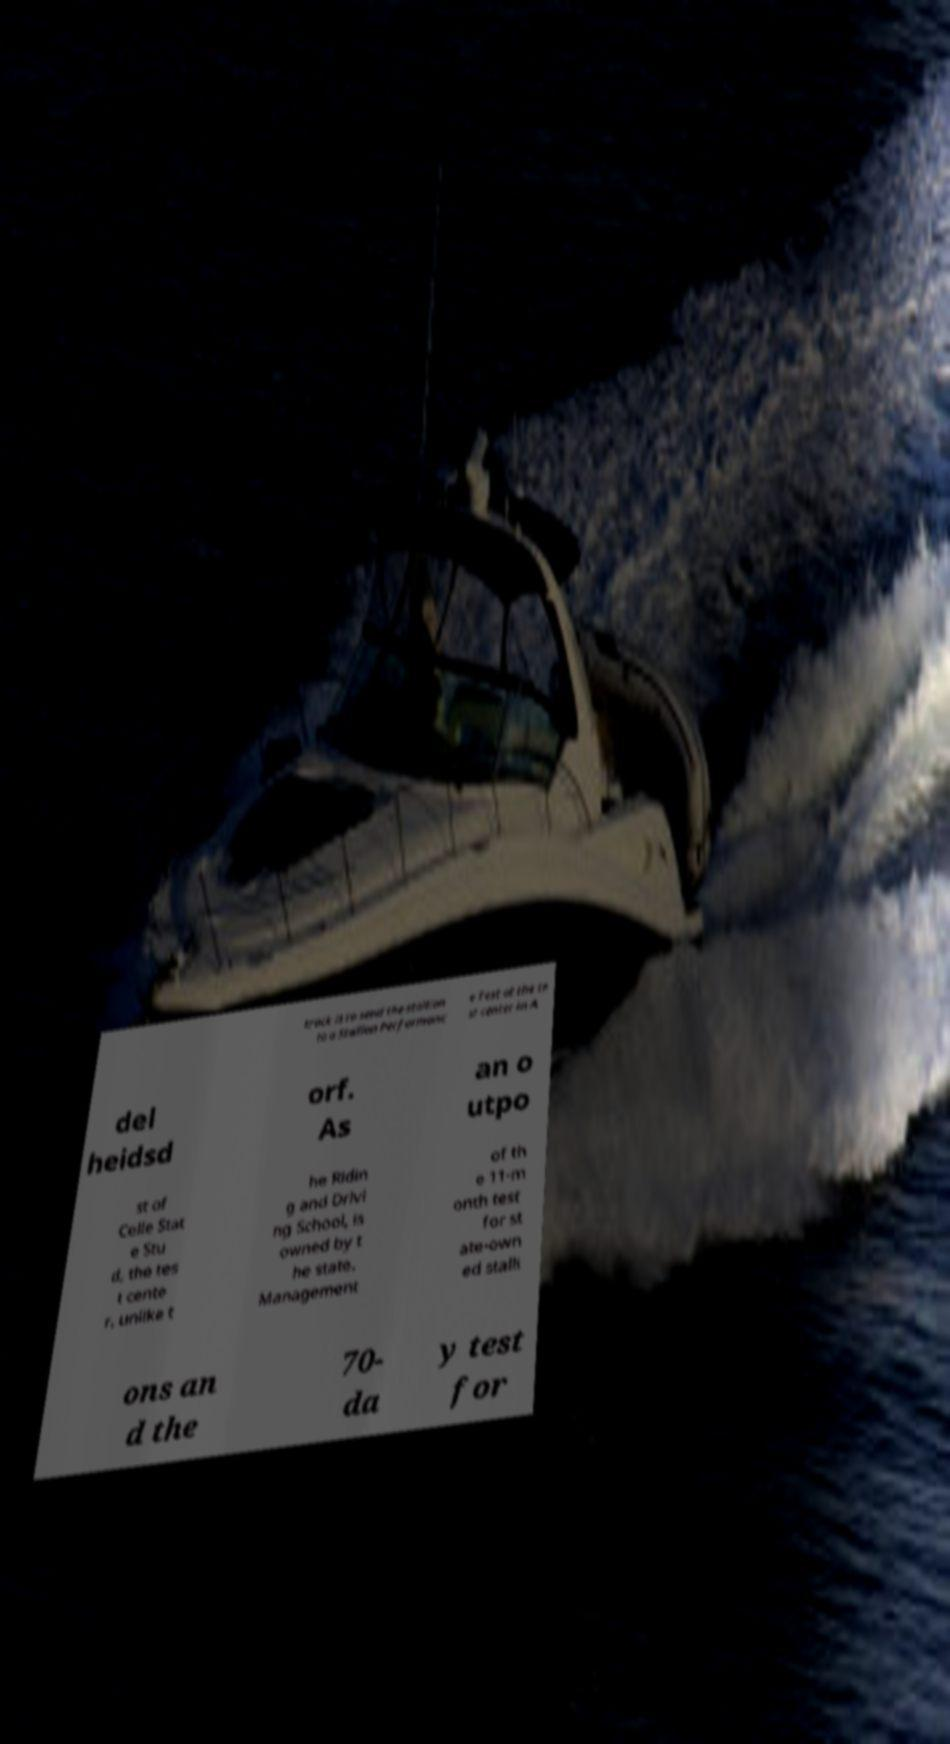Please identify and transcribe the text found in this image. track is to send the stallion to a Stallion Performanc e Test at the te st center in A del heidsd orf. As an o utpo st of Celle Stat e Stu d, the tes t cente r, unlike t he Ridin g and Drivi ng School, is owned by t he state. Management of th e 11-m onth test for st ate-own ed stalli ons an d the 70- da y test for 